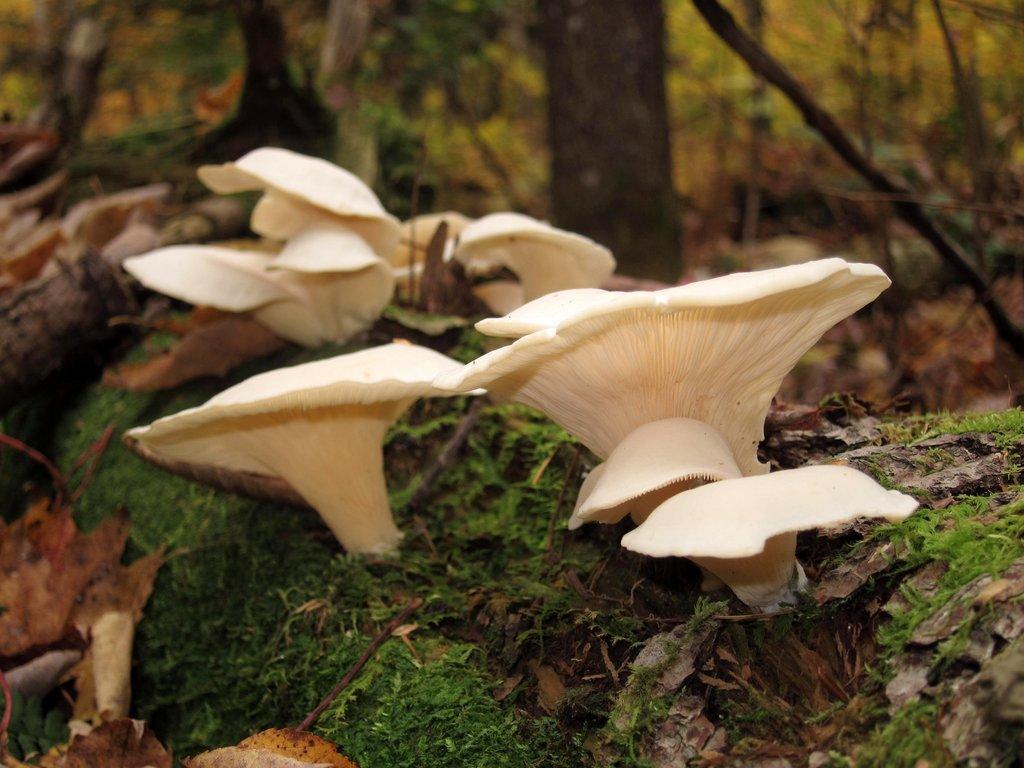In one or two sentences, can you explain what this image depicts? In this image I can see mushroom. They are in cream color. We can see grass and trees. 